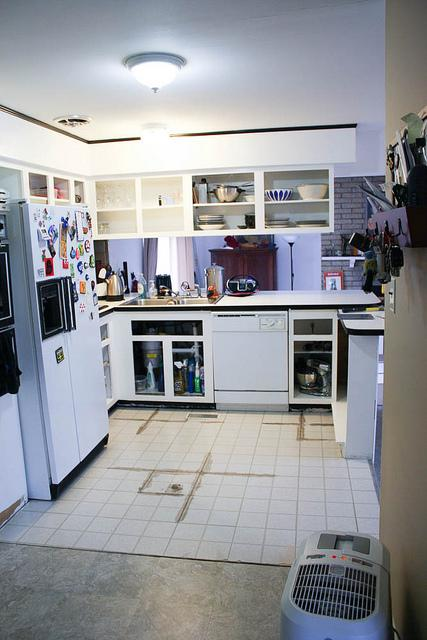What type of floor has been laid in the kitchen? Please explain your reasoning. hardwood. There are small squares of flooring 